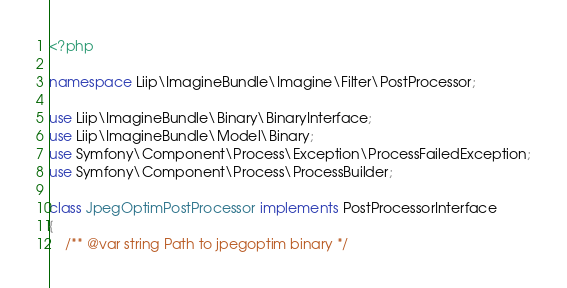<code> <loc_0><loc_0><loc_500><loc_500><_PHP_><?php

namespace Liip\ImagineBundle\Imagine\Filter\PostProcessor;

use Liip\ImagineBundle\Binary\BinaryInterface;
use Liip\ImagineBundle\Model\Binary;
use Symfony\Component\Process\Exception\ProcessFailedException;
use Symfony\Component\Process\ProcessBuilder;

class JpegOptimPostProcessor implements PostProcessorInterface
{
    /** @var string Path to jpegoptim binary */</code> 